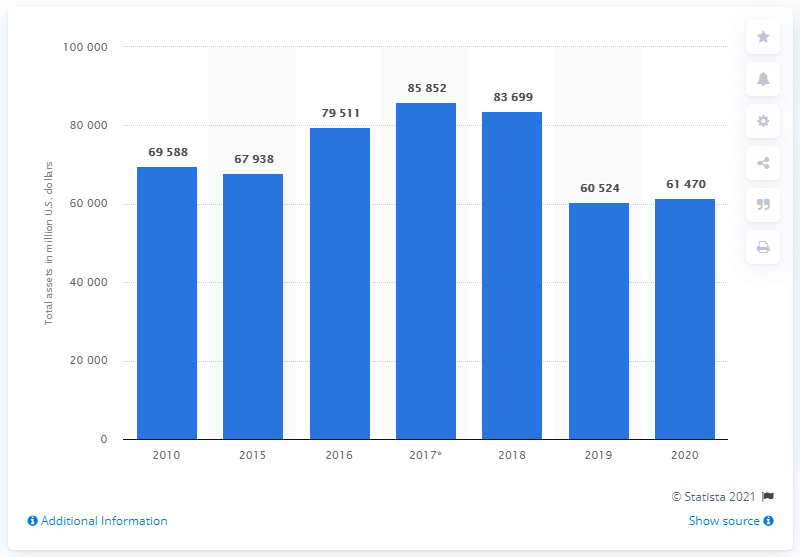List a handful of essential elements in this visual. In 2020, the assets of Dow Chemical were estimated to be worth 61,470 million dollars. 